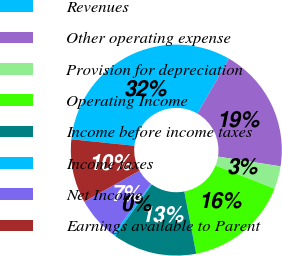Convert chart to OTSL. <chart><loc_0><loc_0><loc_500><loc_500><pie_chart><fcel>Revenues<fcel>Other operating expense<fcel>Provision for depreciation<fcel>Operating Income<fcel>Income before income taxes<fcel>Income taxes<fcel>Net Income<fcel>Earnings available to Parent<nl><fcel>31.68%<fcel>19.15%<fcel>3.5%<fcel>16.02%<fcel>12.89%<fcel>0.37%<fcel>6.63%<fcel>9.76%<nl></chart> 